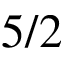<formula> <loc_0><loc_0><loc_500><loc_500>5 / 2</formula> 